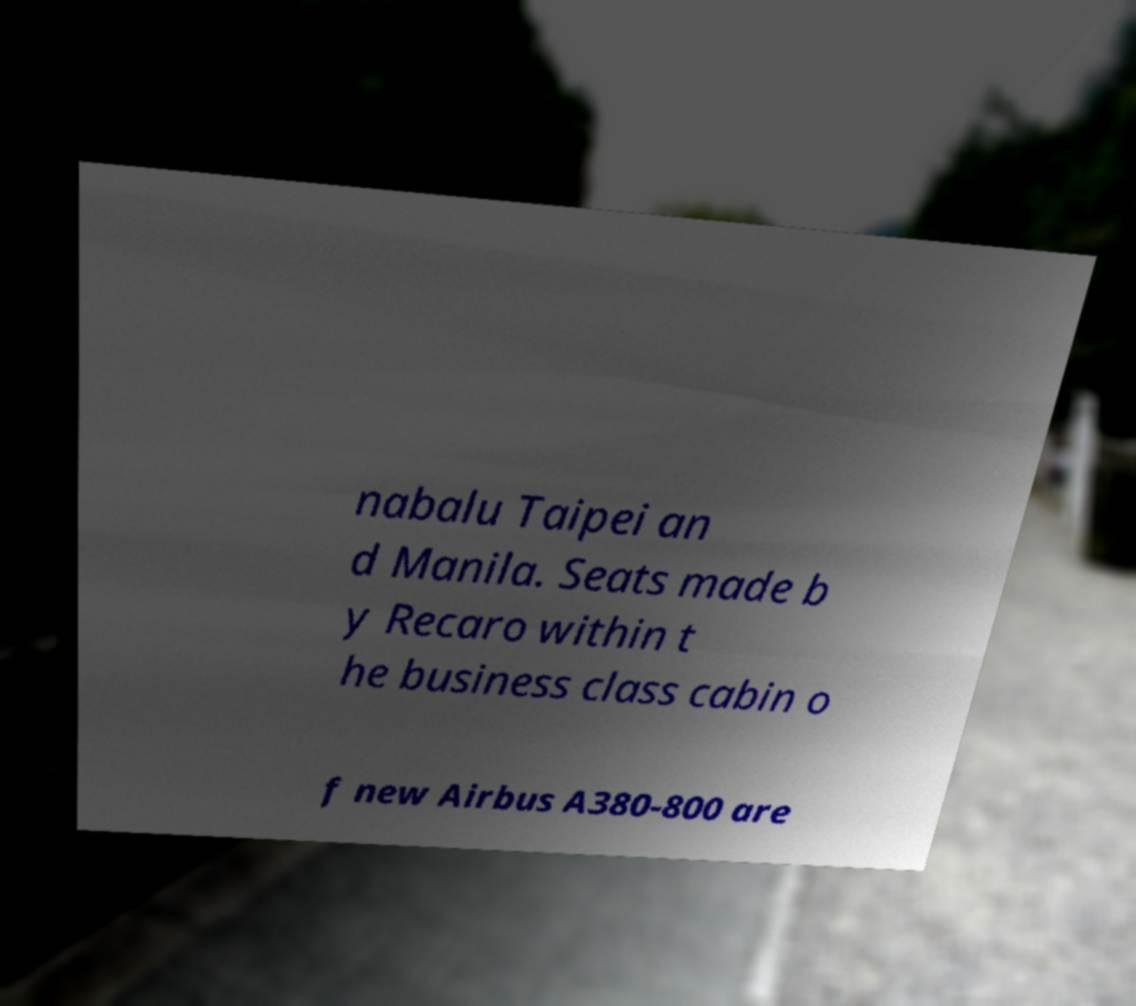Please read and relay the text visible in this image. What does it say? nabalu Taipei an d Manila. Seats made b y Recaro within t he business class cabin o f new Airbus A380-800 are 